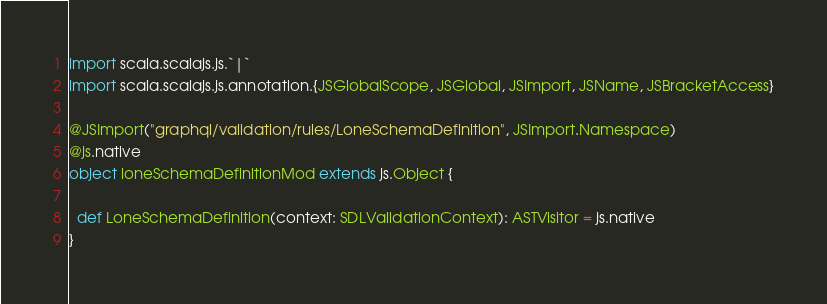Convert code to text. <code><loc_0><loc_0><loc_500><loc_500><_Scala_>import scala.scalajs.js.`|`
import scala.scalajs.js.annotation.{JSGlobalScope, JSGlobal, JSImport, JSName, JSBracketAccess}

@JSImport("graphql/validation/rules/LoneSchemaDefinition", JSImport.Namespace)
@js.native
object loneSchemaDefinitionMod extends js.Object {
  
  def LoneSchemaDefinition(context: SDLValidationContext): ASTVisitor = js.native
}
</code> 